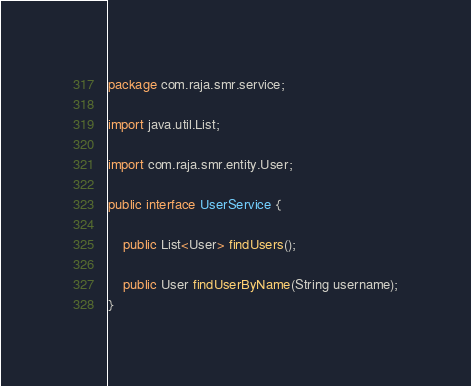Convert code to text. <code><loc_0><loc_0><loc_500><loc_500><_Java_>package com.raja.smr.service;

import java.util.List;

import com.raja.smr.entity.User;

public interface UserService {

	public List<User> findUsers();
	
	public User findUserByName(String username);
}
</code> 